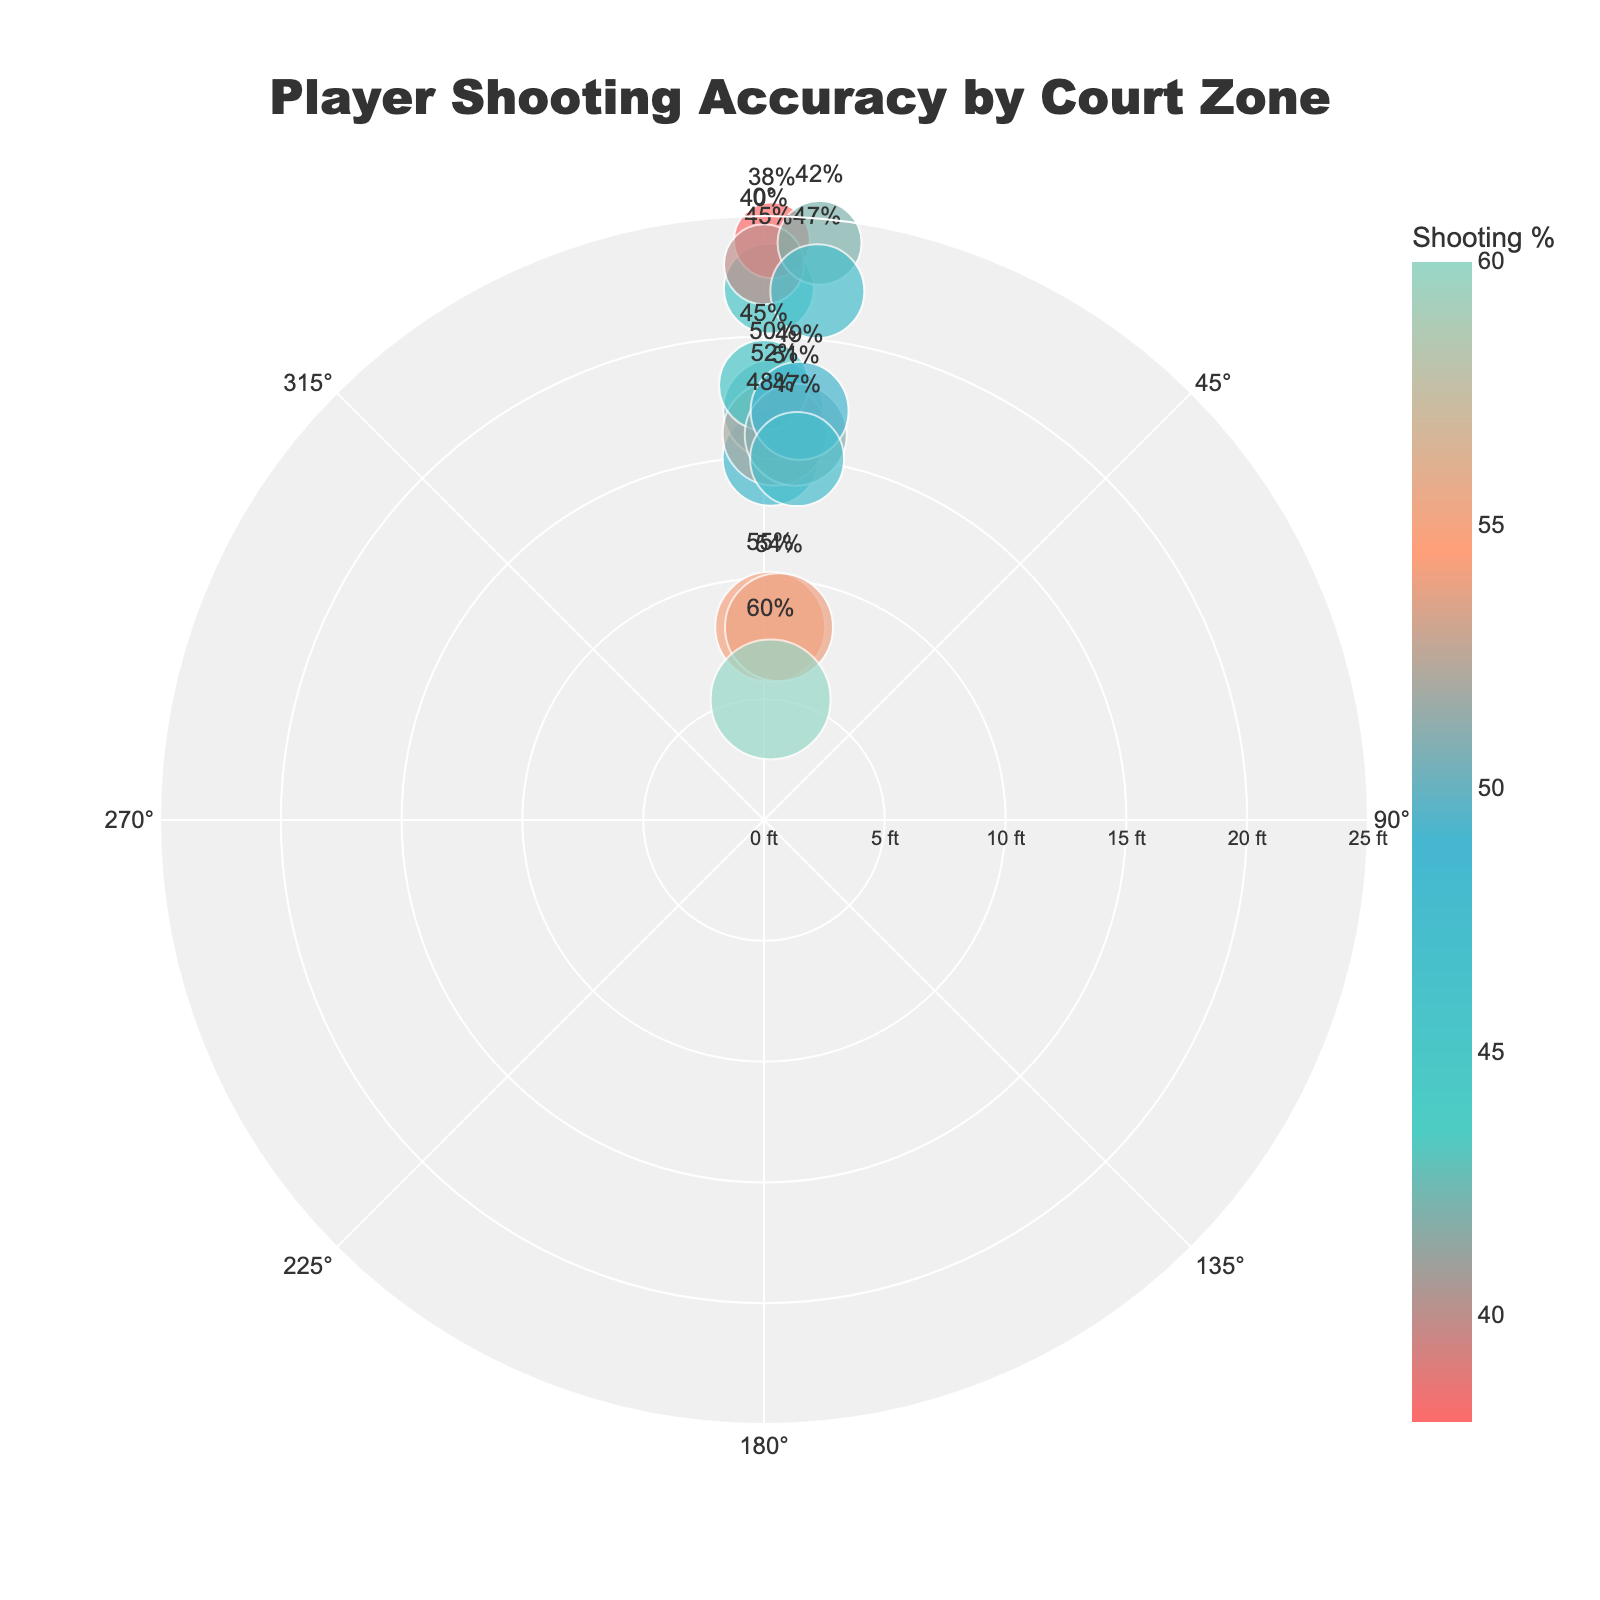what is the title of the figure? The title is usually located at the top of the figure and clearly states what the figure is about. Here, the title is "Player Shooting Accuracy by Court Zone".
Answer: Player Shooting Accuracy by Court Zone How many court zones are displayed in the figure? Each court zone is represented by a marker in the polar scatter plot. By counting the markers, one can determine the number of court zones. There are a total of 15 markers in the plot.
Answer: 15 Which court zone has the highest shooting percentage? By looking at the text annotations on the markers, you can identify that the "Paint" zone has the highest percentage, with a shooting percentage of 60%.
Answer: Paint What is the shooting percentage in the "Right Corner 3" zone? The "Right Corner 3" zone's marker is labeled, making it easy to spot its shooting percentage, which is 47%.
Answer: 47% What is the average shooting percentage for the Mid-Range zones? The Mid-Range zones include various court zones: "Left Baseline Mid-Range", "Left Elbow Mid-Range", "Free Throw Line Extended Left", "Top of the Key Mid-Range", "Free Throw Line Extended Right", "Right Elbow Mid-Range", and "Right Baseline Mid-Range". Their shooting percentages are 48%, 50%, 52%, 45%, 51%, 49%, and 47% respectively. The average can be calculated by summing these percentages and dividing by the number of zones: (48 + 50 + 52 + 45 + 51 + 49 + 47)/7 = 342/7 = 48.86%.
Answer: 48.86% Which court zone has a higher shooting percentage, "Left Corner 3" or "Top of the Key 3"? By comparing the labeled shooting percentages on the coordinate markers, the "Left Corner 3" zone has a percentage of 45%, whereas the "Top of the Key 3" zone has a percentage of 40%. Thus, "Left Corner 3" has a higher shooting percentage.
Answer: Left Corner 3 What is the average distance from the basket for all the three-point zones? The three-point zones include "Left Corner 3", "Left Wing 3", "Top of the Key 3", "Right Wing 3", and "Right Corner 3". Their distances from the basket are 22 ft, 24 ft, 23 ft, 24 ft, and 22 ft, respectively. The average is (22 + 24 + 23 + 24 + 22)/5 = 115/5 = 23 ft.
Answer: 23 ft What is the difference in shooting percentage between the "Left Low Post" and "Right Low Post" zones? The "Left Low Post" and "Right Low Post" zones have shooting percentages of 55% and 54% respectively. The difference between them is 55% - 54% = 1%.
Answer: 1% List the court zones where the shooting percentage is 50% or higher. Reviewing the figure, the zones where the shooting percentage is 50% or higher include: "Left Elbow Mid-Range" (50%), "Free Throw Line Extended Left" (52%), "Free Throw Line Extended Right" (51%), "Right Elbow Mid-Range" (49%), "Left Low Post" (55%), "Right Low Post" (54%), and "Paint" (60%).
Answer: Left Elbow Mid-Range, Free Throw Line Extended Left, Free Throw Line Extended Right, Right Elbow Mid-Range, Left Low Post, Right Low Post, Paint 